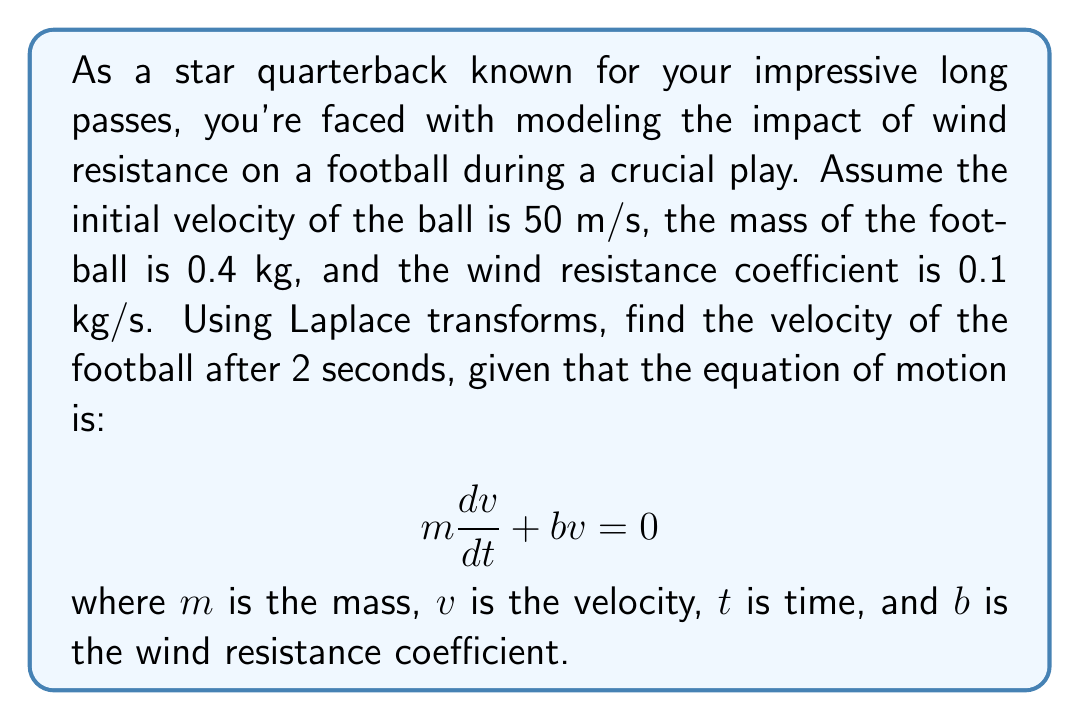Show me your answer to this math problem. Let's solve this problem step by step using Laplace transforms:

1) First, we rewrite the equation in standard form:

   $$\frac{dv}{dt} + \frac{b}{m}v = 0$$

2) Apply the Laplace transform to both sides, using $\mathcal{L}\{v(t)\} = V(s)$ and $\mathcal{L}\{\frac{dv}{dt}\} = sV(s) - v(0)$:

   $$sV(s) - v(0) + \frac{b}{m}V(s) = 0$$

3) Substitute the given values: $m = 0.4$ kg, $b = 0.1$ kg/s, $v(0) = 50$ m/s:

   $$sV(s) - 50 + \frac{0.1}{0.4}V(s) = 0$$

4) Simplify:

   $$sV(s) + 0.25V(s) = 50$$
   $$(s + 0.25)V(s) = 50$$

5) Solve for $V(s)$:

   $$V(s) = \frac{50}{s + 0.25}$$

6) This is in the form of $\frac{A}{s + a}$, which has the inverse Laplace transform $Ae^{-at}$. Therefore:

   $$v(t) = 50e^{-0.25t}$$

7) To find the velocity after 2 seconds, we substitute $t = 2$:

   $$v(2) = 50e^{-0.25(2)} = 50e^{-0.5}$$

8) Calculate the final result:

   $$v(2) = 50 * 0.6065 = 30.325\text{ m/s}$$
Answer: The velocity of the football after 2 seconds is approximately 30.325 m/s. 